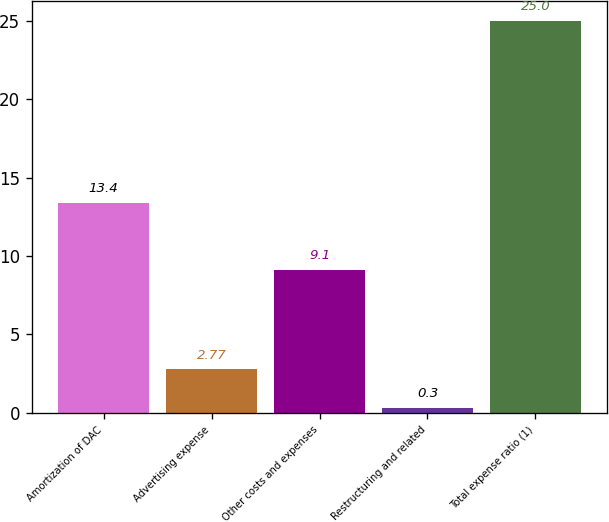Convert chart. <chart><loc_0><loc_0><loc_500><loc_500><bar_chart><fcel>Amortization of DAC<fcel>Advertising expense<fcel>Other costs and expenses<fcel>Restructuring and related<fcel>Total expense ratio (1)<nl><fcel>13.4<fcel>2.77<fcel>9.1<fcel>0.3<fcel>25<nl></chart> 